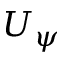Convert formula to latex. <formula><loc_0><loc_0><loc_500><loc_500>U _ { \psi }</formula> 